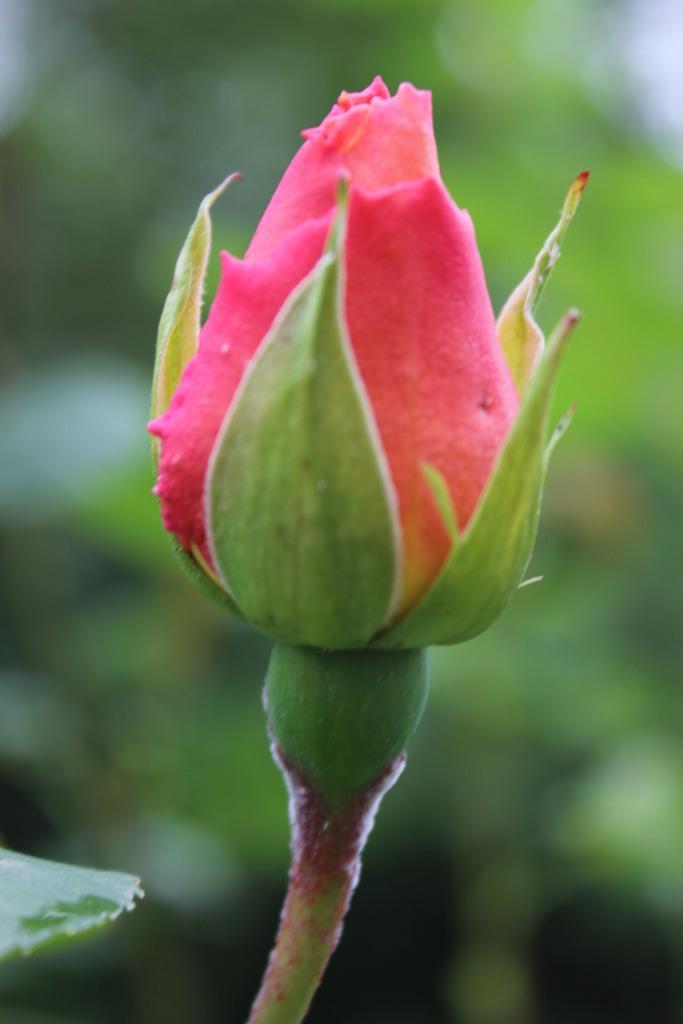Describe this image in one or two sentences. In this image we can see a bud and blur background. 